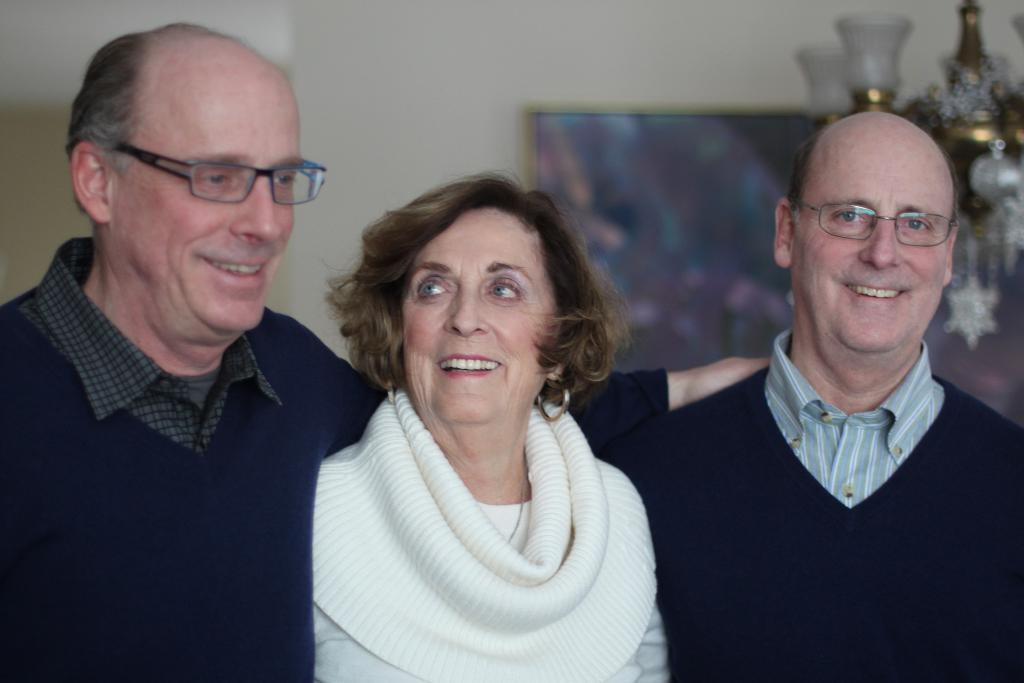How would you summarize this image in a sentence or two? In this image, we can see three persons are there side by side and smiling. On the right side of the image, we can see a person is watching. Background we can see the blur view. Here there is a wall, frame and chandelier. 